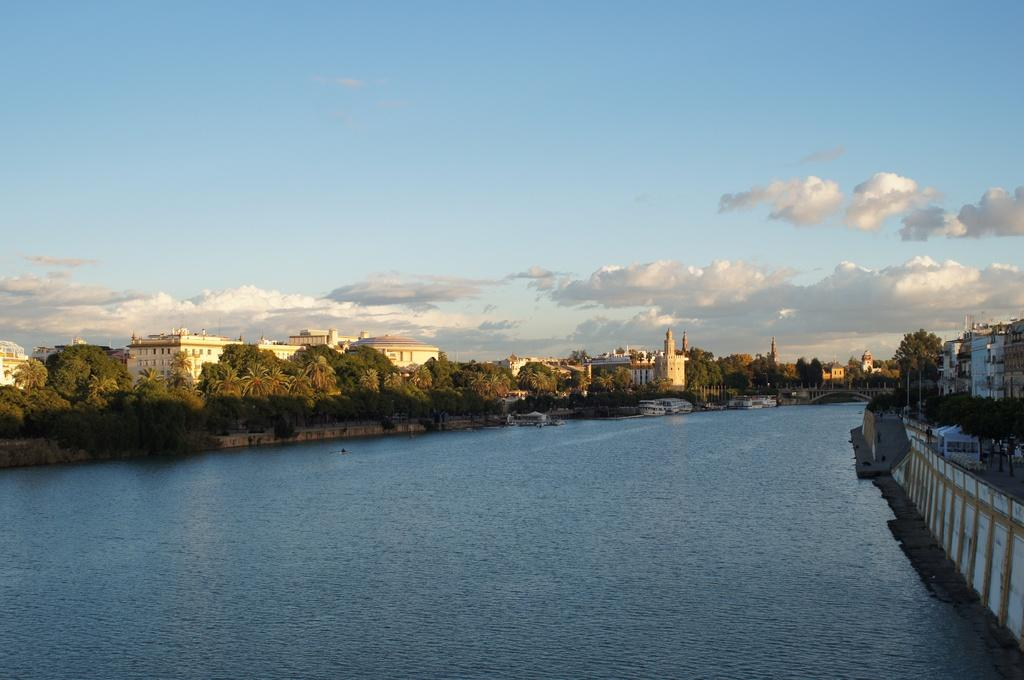What is the primary element visible in the image? There is water in the image. What other natural elements can be seen in the image? There are trees in the image. Are there any man-made structures visible? Yes, there are buildings in the image. What is visible in the background of the image? The sky is visible in the image, and clouds are present in the sky. How many children are playing near the water in the image? There are no children present in the image; it only features water, trees, buildings, and the sky. 